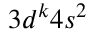Convert formula to latex. <formula><loc_0><loc_0><loc_500><loc_500>3 d ^ { k } 4 s ^ { 2 }</formula> 